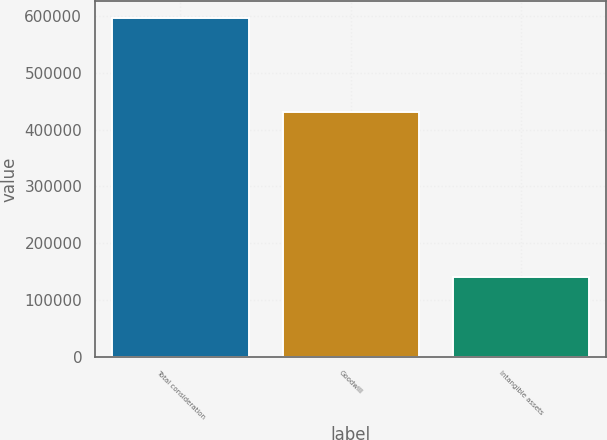Convert chart. <chart><loc_0><loc_0><loc_500><loc_500><bar_chart><fcel>Total consideration<fcel>Goodwill<fcel>Intangible assets<nl><fcel>596148<fcel>431087<fcel>140403<nl></chart> 